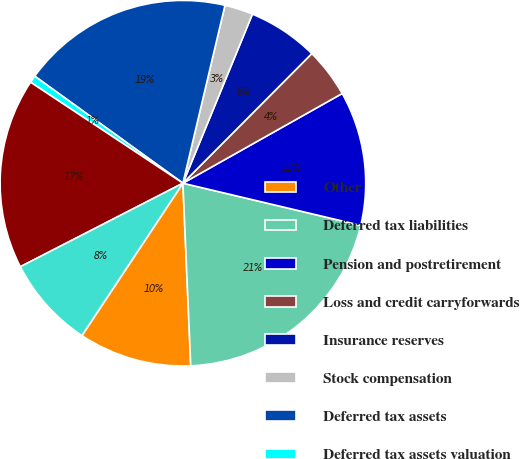Convert chart to OTSL. <chart><loc_0><loc_0><loc_500><loc_500><pie_chart><fcel>Other<fcel>Deferred tax liabilities<fcel>Pension and postretirement<fcel>Loss and credit carryforwards<fcel>Insurance reserves<fcel>Stock compensation<fcel>Deferred tax assets<fcel>Deferred tax assets valuation<fcel>Deferred tax asset (net of<fcel>Net deferred tax asset<nl><fcel>10.0%<fcel>20.61%<fcel>11.87%<fcel>4.38%<fcel>6.25%<fcel>2.51%<fcel>18.74%<fcel>0.64%<fcel>16.87%<fcel>8.13%<nl></chart> 